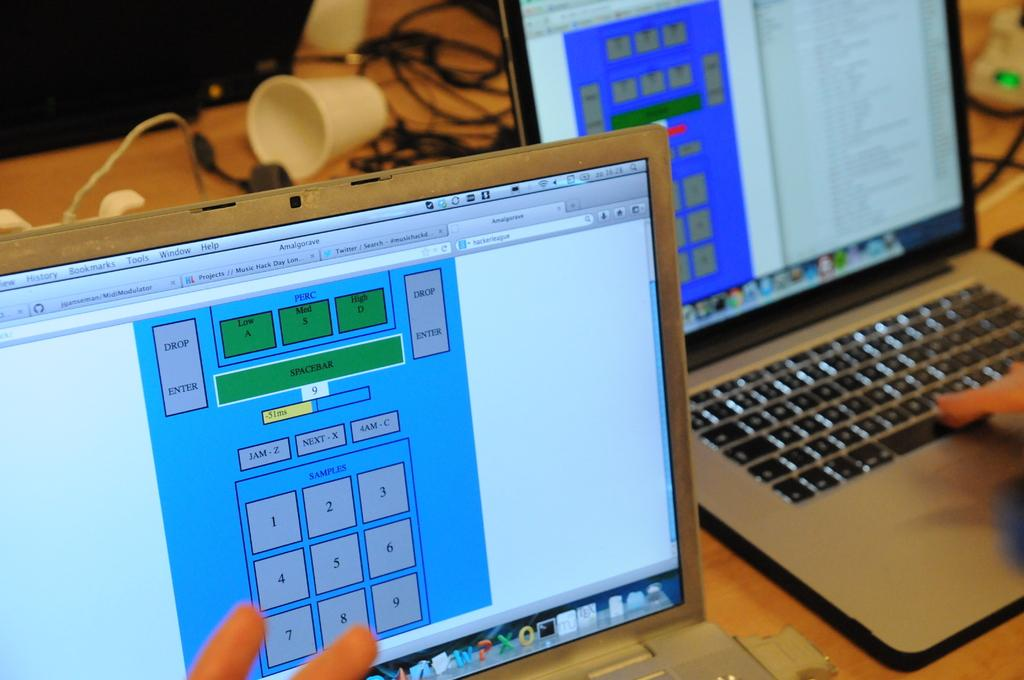<image>
Present a compact description of the photo's key features. Two computers on a table are showing a screen from MidiModulator. 